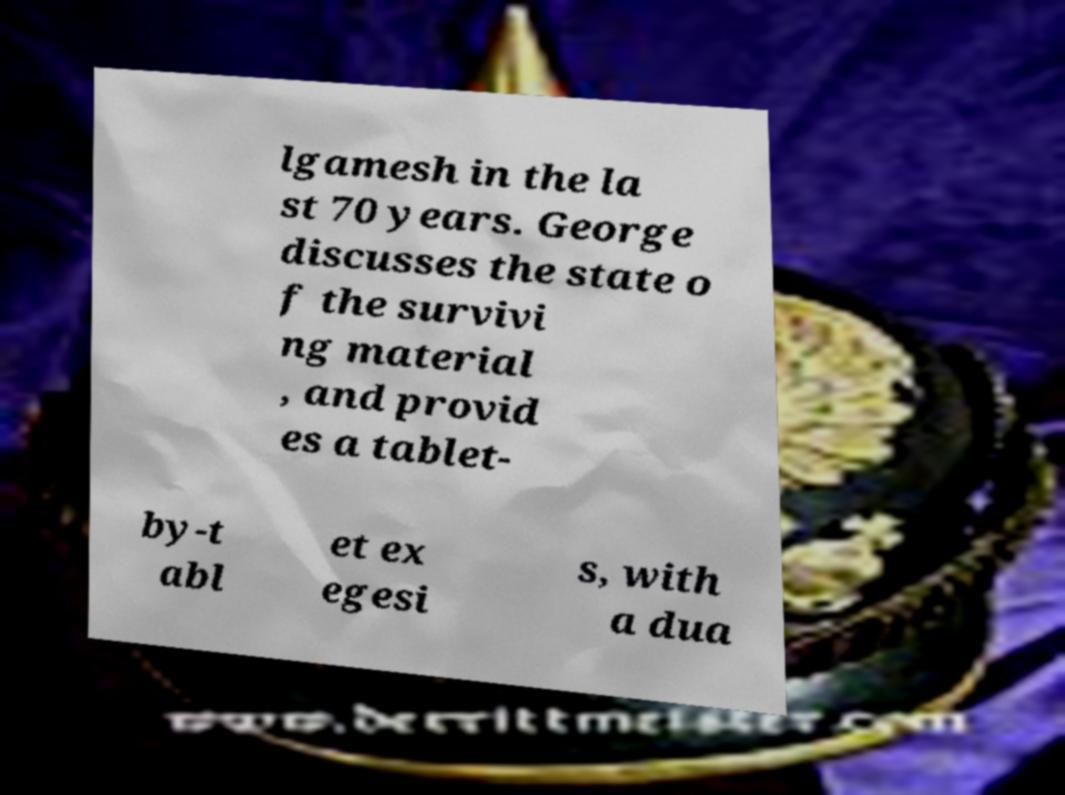Could you assist in decoding the text presented in this image and type it out clearly? lgamesh in the la st 70 years. George discusses the state o f the survivi ng material , and provid es a tablet- by-t abl et ex egesi s, with a dua 